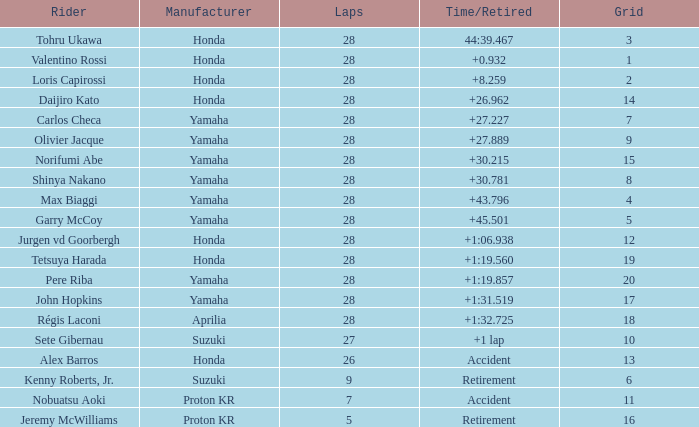Which grid contains laps more than 26, and a time/retired duration of 44:3 3.0. 